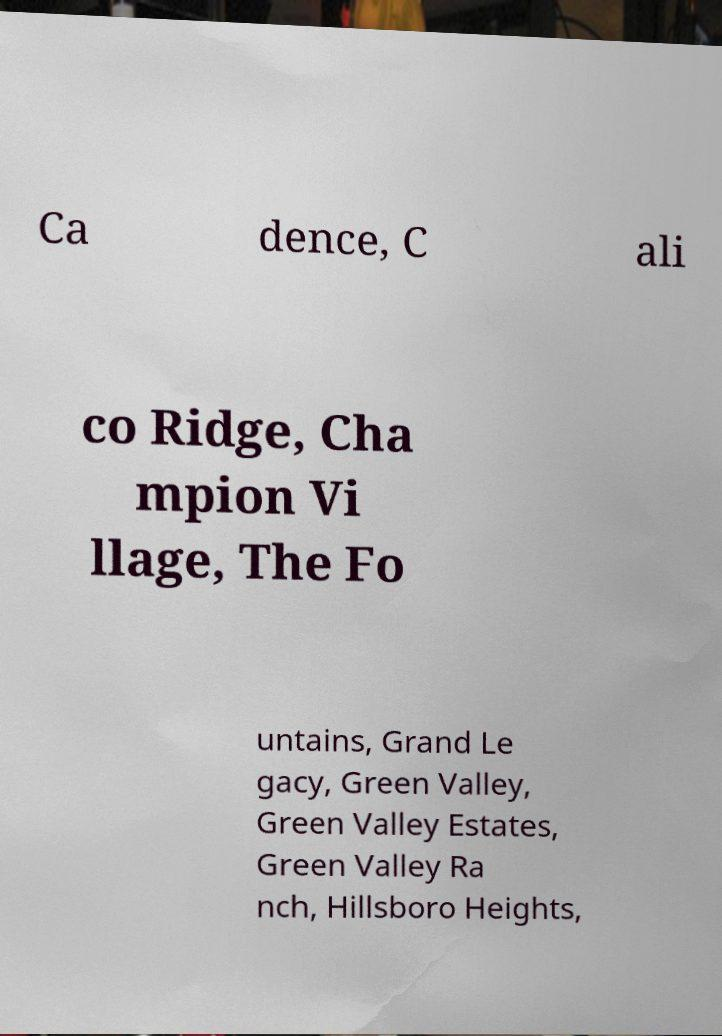For documentation purposes, I need the text within this image transcribed. Could you provide that? Ca dence, C ali co Ridge, Cha mpion Vi llage, The Fo untains, Grand Le gacy, Green Valley, Green Valley Estates, Green Valley Ra nch, Hillsboro Heights, 